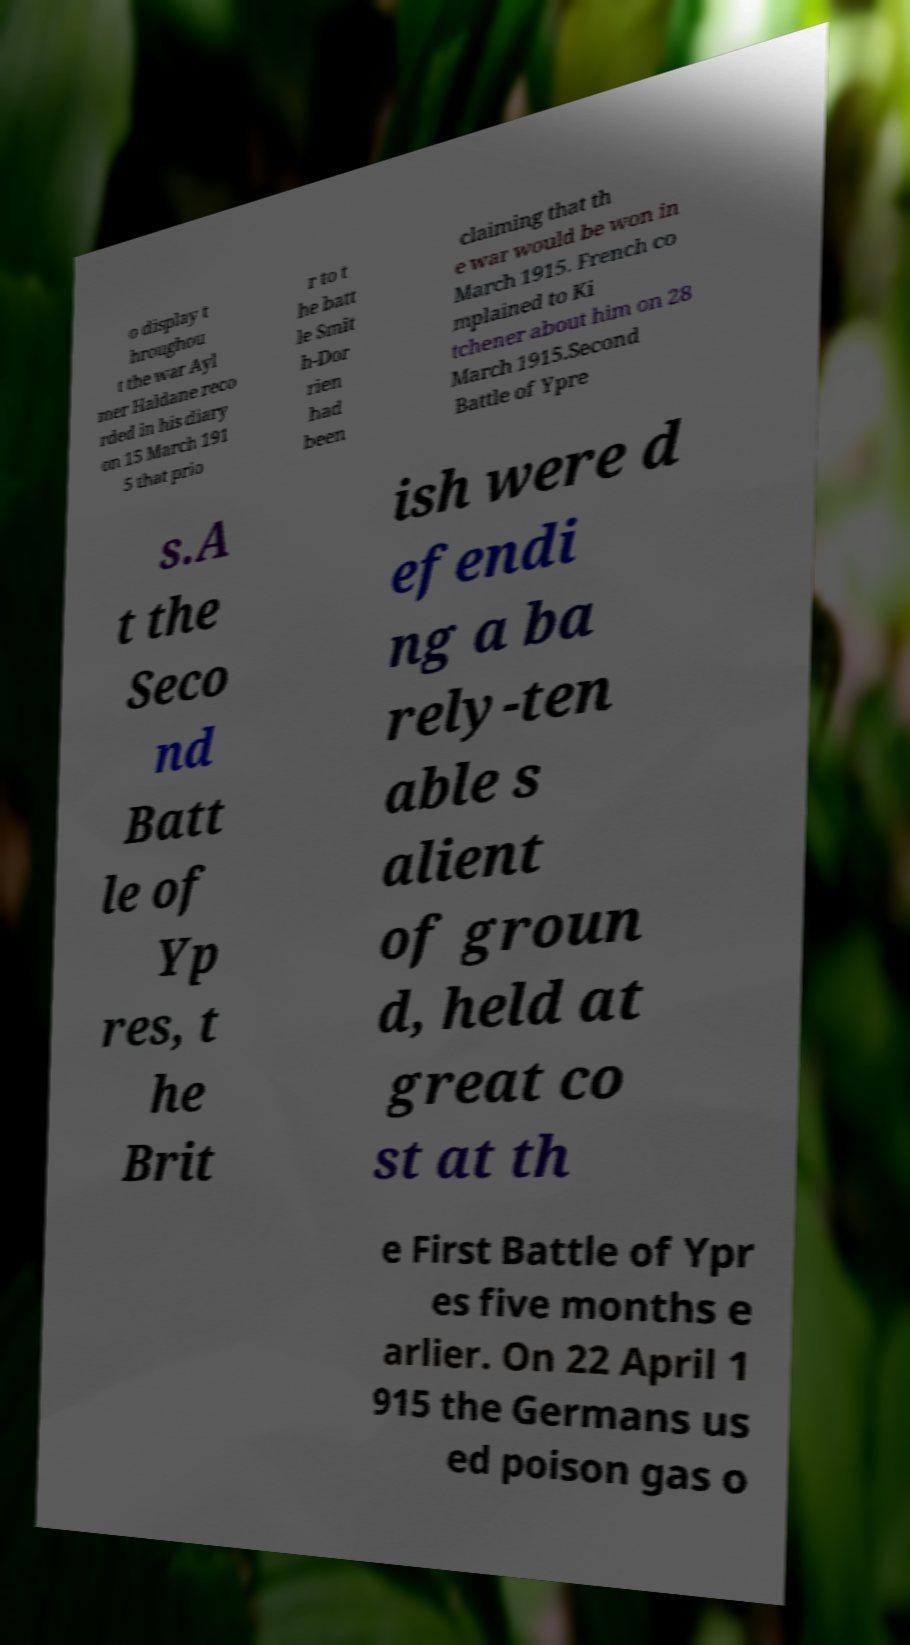Can you accurately transcribe the text from the provided image for me? o display t hroughou t the war Ayl mer Haldane reco rded in his diary on 15 March 191 5 that prio r to t he batt le Smit h-Dor rien had been claiming that th e war would be won in March 1915. French co mplained to Ki tchener about him on 28 March 1915.Second Battle of Ypre s.A t the Seco nd Batt le of Yp res, t he Brit ish were d efendi ng a ba rely-ten able s alient of groun d, held at great co st at th e First Battle of Ypr es five months e arlier. On 22 April 1 915 the Germans us ed poison gas o 